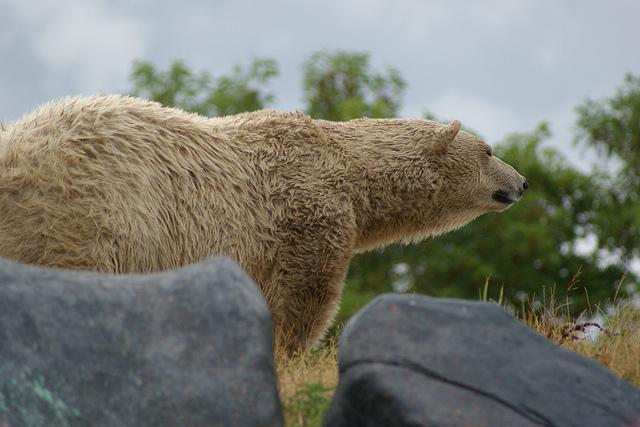How many people aren't holding their phone?
Give a very brief answer. 0. 